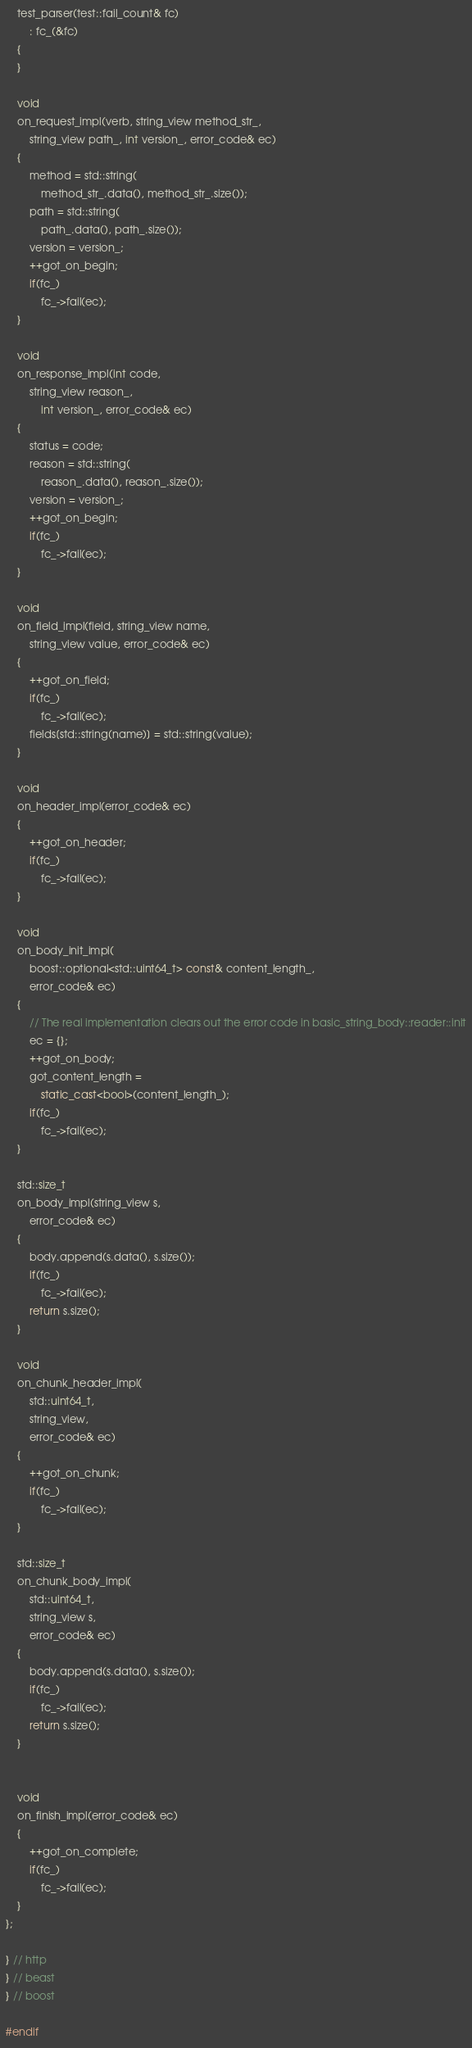Convert code to text. <code><loc_0><loc_0><loc_500><loc_500><_C++_>    test_parser(test::fail_count& fc)
        : fc_(&fc)
    {
    }

    void
    on_request_impl(verb, string_view method_str_,
        string_view path_, int version_, error_code& ec)
    {
        method = std::string(
            method_str_.data(), method_str_.size());
        path = std::string(
            path_.data(), path_.size());
        version = version_;
        ++got_on_begin;
        if(fc_)
            fc_->fail(ec);
    }

    void
    on_response_impl(int code,
        string_view reason_,
            int version_, error_code& ec)
    {
        status = code;
        reason = std::string(
            reason_.data(), reason_.size());
        version = version_;
        ++got_on_begin;
        if(fc_)
            fc_->fail(ec);
    }

    void
    on_field_impl(field, string_view name,
        string_view value, error_code& ec)
    {
        ++got_on_field;
        if(fc_)
            fc_->fail(ec);
        fields[std::string(name)] = std::string(value);
    }

    void
    on_header_impl(error_code& ec)
    {
        ++got_on_header;
        if(fc_)
            fc_->fail(ec);
    }

    void
    on_body_init_impl(
        boost::optional<std::uint64_t> const& content_length_,
        error_code& ec)
    {
        // The real implementation clears out the error code in basic_string_body::reader::init
        ec = {};
        ++got_on_body;
        got_content_length =
            static_cast<bool>(content_length_);
        if(fc_)
            fc_->fail(ec);
    }

    std::size_t
    on_body_impl(string_view s,
        error_code& ec)
    {
        body.append(s.data(), s.size());
        if(fc_)
            fc_->fail(ec);
        return s.size();
    }

    void
    on_chunk_header_impl(
        std::uint64_t,
        string_view,
        error_code& ec)
    {
        ++got_on_chunk;
        if(fc_)
            fc_->fail(ec);
    }

    std::size_t
    on_chunk_body_impl(
        std::uint64_t,
        string_view s,
        error_code& ec)
    {
        body.append(s.data(), s.size());
        if(fc_)
            fc_->fail(ec);
        return s.size();
    }


    void
    on_finish_impl(error_code& ec)
    {
        ++got_on_complete;
        if(fc_)
            fc_->fail(ec);
    }
};

} // http
} // beast
} // boost

#endif
</code> 